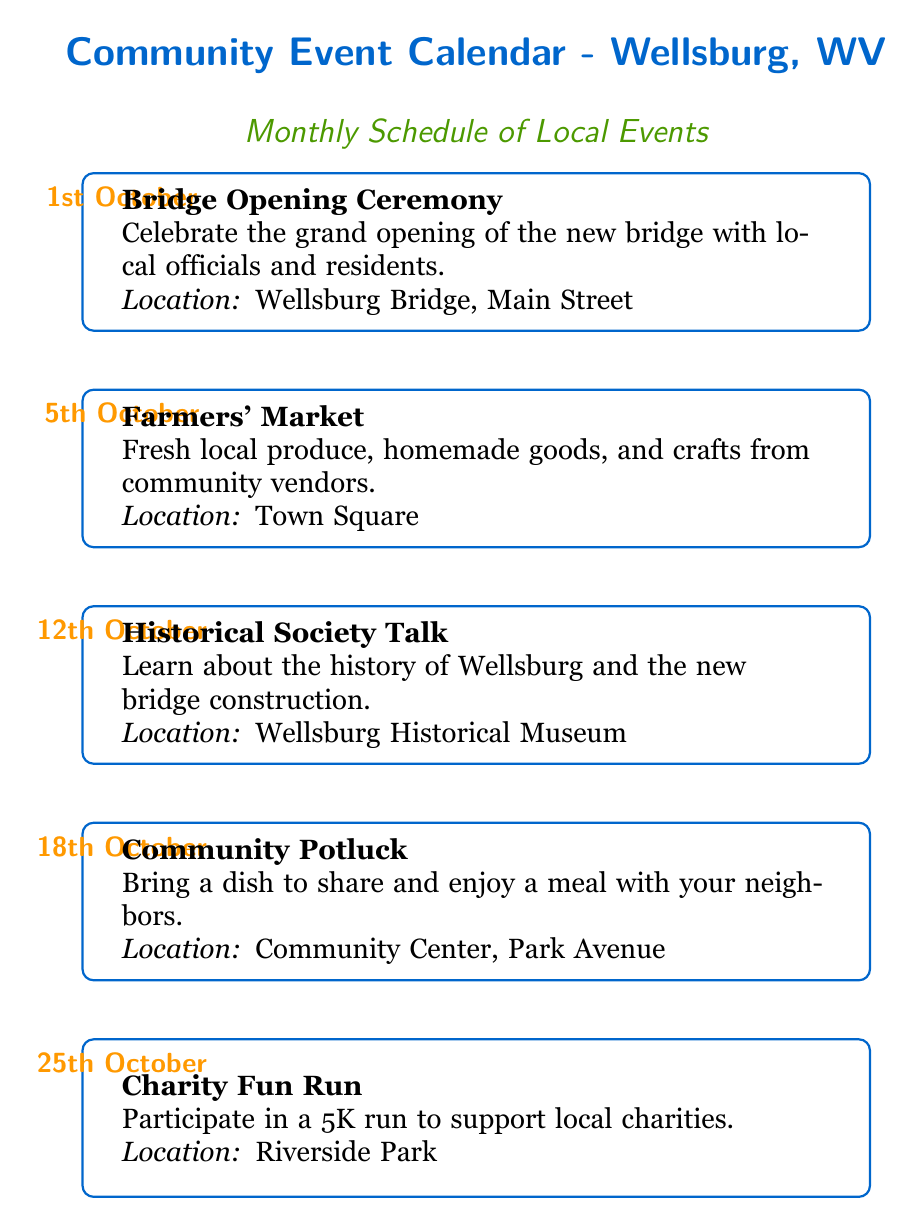What is the first event listed on the calendar? The first event listed on the calendar is found at the top of the diagram. According to the date node at "-4.5,6.2", the event associated with this date is "1st October," which corresponds to the "Bridge Opening Ceremony."
Answer: Bridge Opening Ceremony How many events are scheduled for October? By examining the diagram, we can count the number of events scheduled. There are five distinct events listed on the calendar for the month of October, as denoted by the individual date nodes.
Answer: 5 What is the date of the Charity Fun Run event? Looking at the event nodes, the "Charity Fun Run" occurs on "25th October" as indicated by the date node at "-4.5,-4.8."
Answer: 25th October Where is the Historical Society Talk event located? The location of the "Historical Society Talk" is specified directly in the corresponding event node. It states that the location is the "Wellsburg Historical Museum."
Answer: Wellsburg Historical Museum What type of event is happening on the 18th of October? To determine the type of event for "18th October," check the associated event node. It describes the event as a "Community Potluck," which involves sharing a meal with neighbors.
Answer: Community Potluck Which event takes place two weeks after the opening ceremony? The "Bridge Opening Ceremony" occurs on "1st October." By calculating two weeks later, we determine that the next event on the calendar is the "Farmers' Market," which takes place on "5th October."
Answer: Farmers' Market What is the least frequently mentioned location in the events? To identify the least frequently mentioned location, we can examine each event's location. The Riverside Park is mentioned only once for the "Charity Fun Run," while other locations are mentioned more than once. Therefore, it stands out as the least frequent.
Answer: Riverside Park How many events occur before the Community Potluck? To find the number of events that occur before the "Community Potluck," we look at the events listed before it in the diagram. The events are "Bridge Opening Ceremony," "Farmers' Market," and "Historical Society Talk," totaling three events that occur prior.
Answer: 3 What is the purpose of the Charity Fun Run event? The purpose of the "Charity Fun Run" is explicitly stated in the event description, indicating it is to support local charities.
Answer: support local charities 